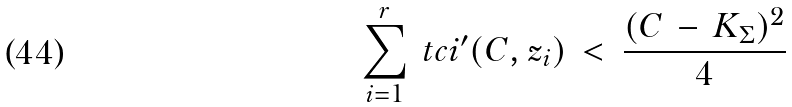Convert formula to latex. <formula><loc_0><loc_0><loc_500><loc_500>\sum _ { i = 1 } ^ { r } \ t c i ^ { \prime } ( C , z _ { i } ) \, < \, \frac { ( C \, - \, K _ { \Sigma } ) ^ { 2 } } { 4 }</formula> 